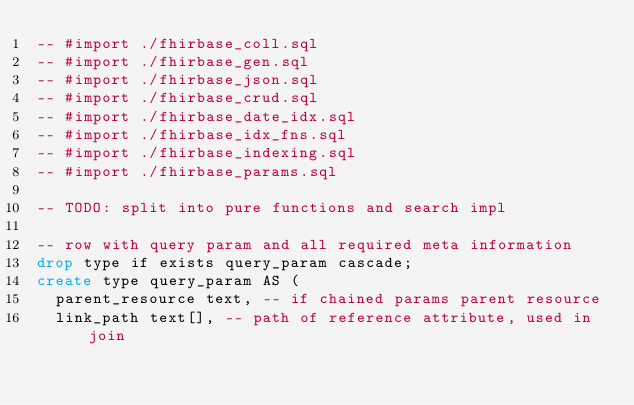Convert code to text. <code><loc_0><loc_0><loc_500><loc_500><_SQL_>-- #import ./fhirbase_coll.sql
-- #import ./fhirbase_gen.sql
-- #import ./fhirbase_json.sql
-- #import ./fhirbase_crud.sql
-- #import ./fhirbase_date_idx.sql
-- #import ./fhirbase_idx_fns.sql
-- #import ./fhirbase_indexing.sql
-- #import ./fhirbase_params.sql

-- TODO: split into pure functions and search impl

-- row with query param and all required meta information
drop type if exists query_param cascade;
create type query_param AS (
  parent_resource text, -- if chained params parent resource
  link_path text[], -- path of reference attribute, used in join</code> 